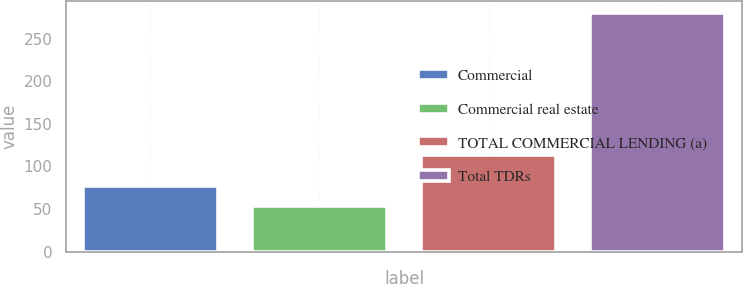<chart> <loc_0><loc_0><loc_500><loc_500><bar_chart><fcel>Commercial<fcel>Commercial real estate<fcel>TOTAL COMMERCIAL LENDING (a)<fcel>Total TDRs<nl><fcel>76.6<fcel>54<fcel>114<fcel>280<nl></chart> 